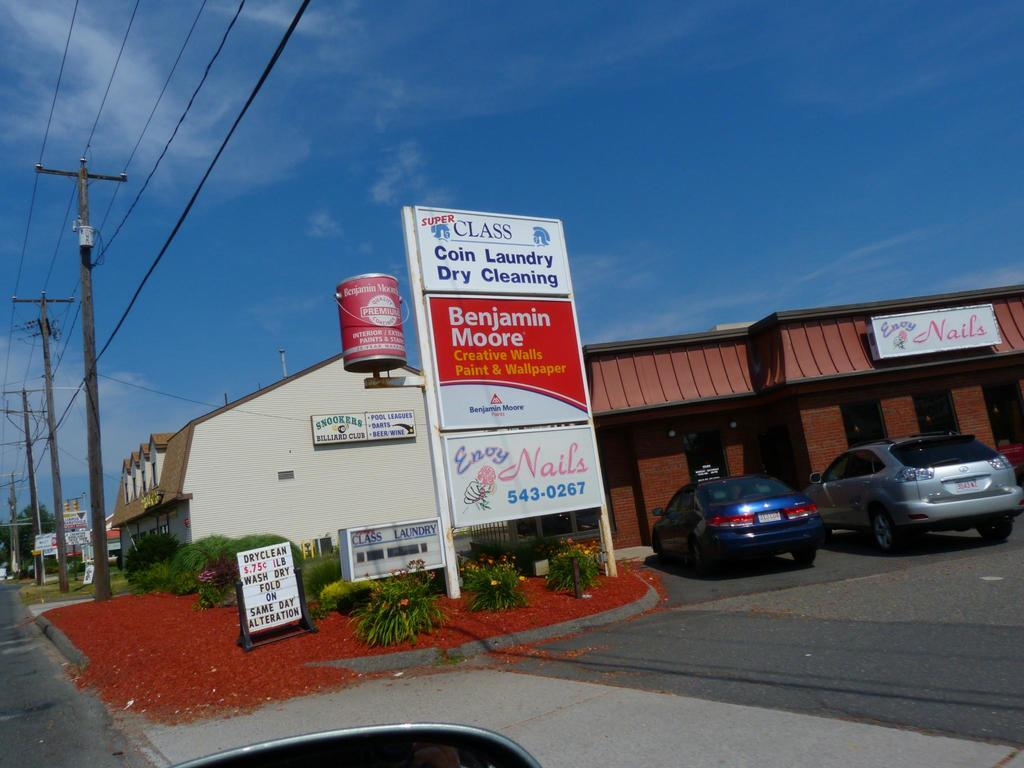Provide a one-sentence caption for the provided image. a shopping plaza with a coin laundry establishment in it. 